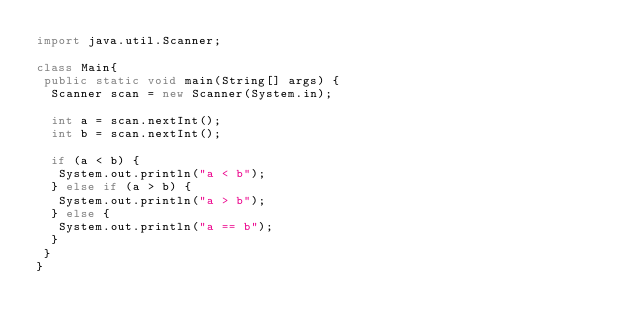Convert code to text. <code><loc_0><loc_0><loc_500><loc_500><_Java_>import java.util.Scanner;

class Main{
 public static void main(String[] args) {
  Scanner scan = new Scanner(System.in);

  int a = scan.nextInt();
  int b = scan.nextInt();

  if (a < b) {
   System.out.println("a < b");
  } else if (a > b) {
   System.out.println("a > b");
  } else {
   System.out.println("a == b");
  }
 }
}</code> 